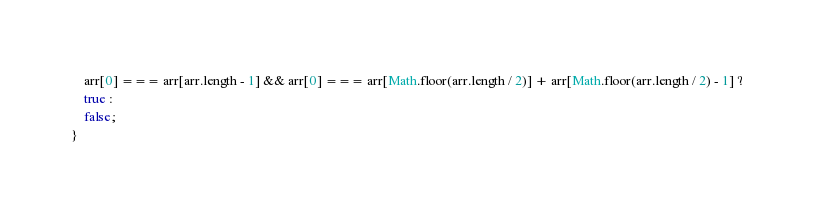Convert code to text. <code><loc_0><loc_0><loc_500><loc_500><_JavaScript_>    arr[0] === arr[arr.length - 1] && arr[0] === arr[Math.floor(arr.length / 2)] + arr[Math.floor(arr.length / 2) - 1] ?
    true :
    false;
}
</code> 